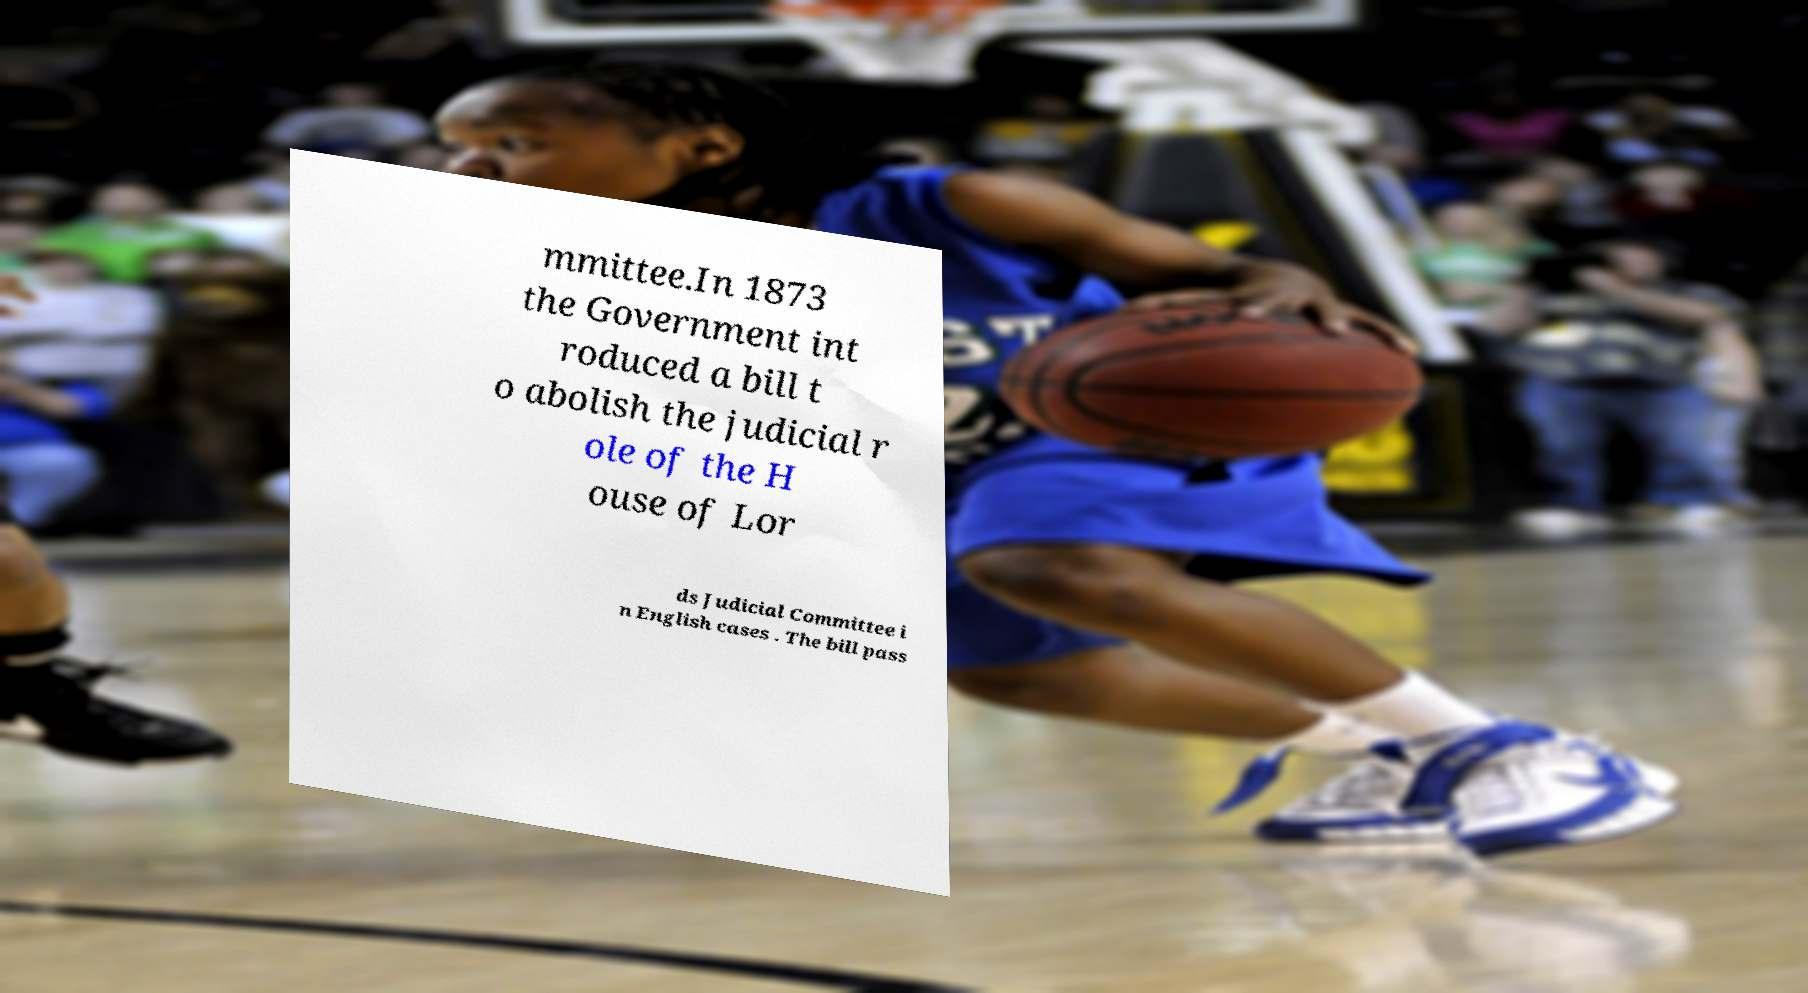For documentation purposes, I need the text within this image transcribed. Could you provide that? mmittee.In 1873 the Government int roduced a bill t o abolish the judicial r ole of the H ouse of Lor ds Judicial Committee i n English cases . The bill pass 